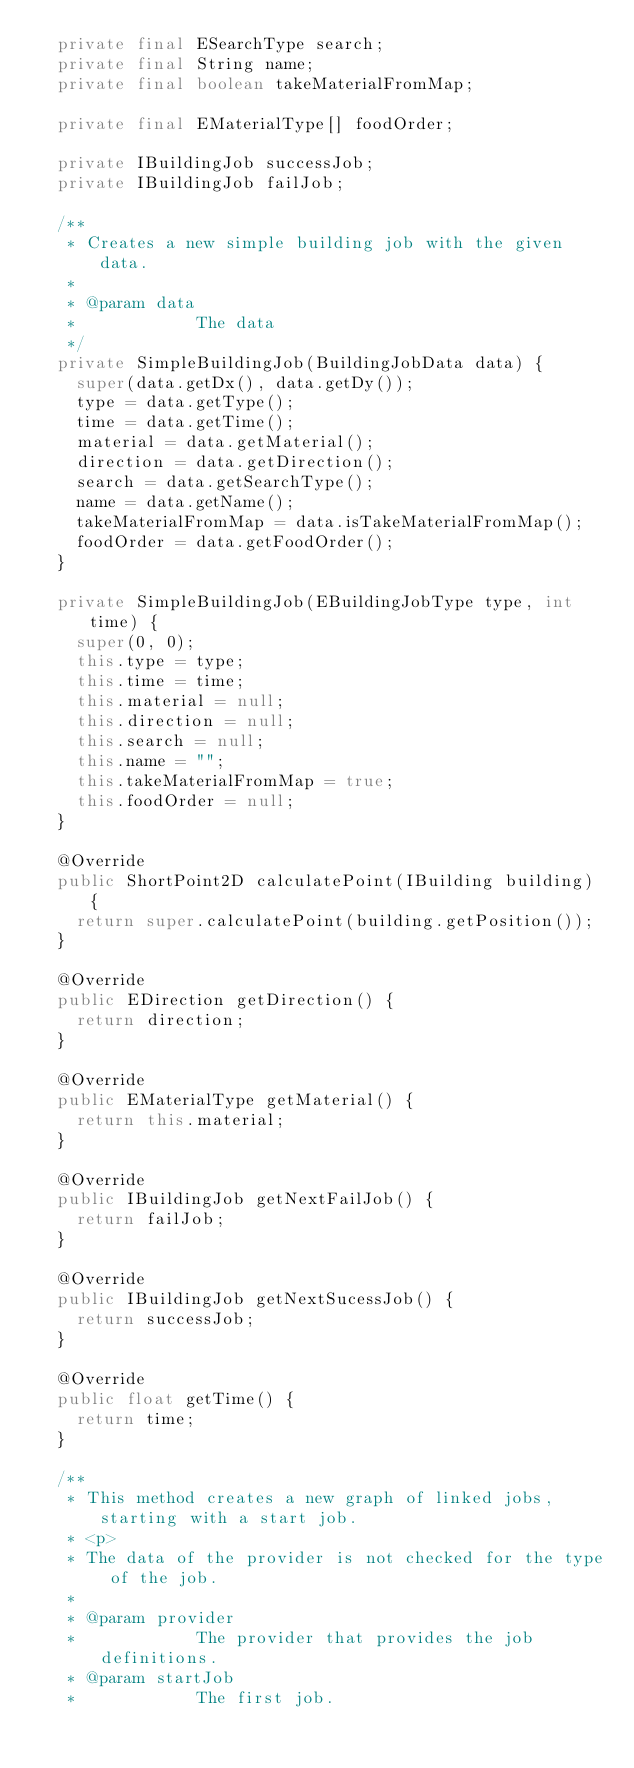Convert code to text. <code><loc_0><loc_0><loc_500><loc_500><_Java_>	private final ESearchType search;
	private final String name;
	private final boolean takeMaterialFromMap;

	private final EMaterialType[] foodOrder;

	private IBuildingJob successJob;
	private IBuildingJob failJob;

	/**
	 * Creates a new simple building job with the given data.
	 * 
	 * @param data
	 *            The data
	 */
	private SimpleBuildingJob(BuildingJobData data) {
		super(data.getDx(), data.getDy());
		type = data.getType();
		time = data.getTime();
		material = data.getMaterial();
		direction = data.getDirection();
		search = data.getSearchType();
		name = data.getName();
		takeMaterialFromMap = data.isTakeMaterialFromMap();
		foodOrder = data.getFoodOrder();
	}

	private SimpleBuildingJob(EBuildingJobType type, int time) {
		super(0, 0);
		this.type = type;
		this.time = time;
		this.material = null;
		this.direction = null;
		this.search = null;
		this.name = "";
		this.takeMaterialFromMap = true;
		this.foodOrder = null;
	}

	@Override
	public ShortPoint2D calculatePoint(IBuilding building) {
		return super.calculatePoint(building.getPosition());
	}

	@Override
	public EDirection getDirection() {
		return direction;
	}

	@Override
	public EMaterialType getMaterial() {
		return this.material;
	}

	@Override
	public IBuildingJob getNextFailJob() {
		return failJob;
	}

	@Override
	public IBuildingJob getNextSucessJob() {
		return successJob;
	}

	@Override
	public float getTime() {
		return time;
	}

	/**
	 * This method creates a new graph of linked jobs, starting with a start job.
	 * <p>
	 * The data of the provider is not checked for the type of the job.
	 * 
	 * @param provider
	 *            The provider that provides the job definitions.
	 * @param startJob
	 *            The first job.</code> 